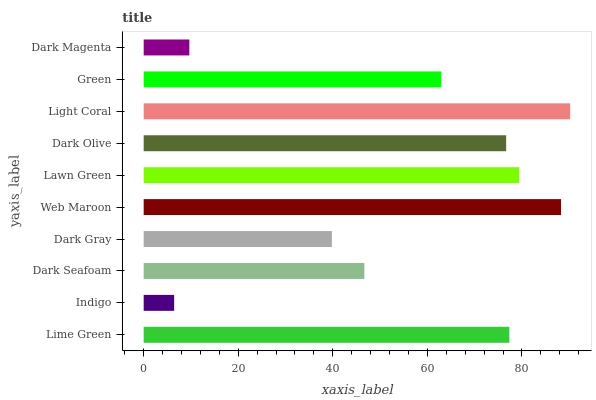Is Indigo the minimum?
Answer yes or no. Yes. Is Light Coral the maximum?
Answer yes or no. Yes. Is Dark Seafoam the minimum?
Answer yes or no. No. Is Dark Seafoam the maximum?
Answer yes or no. No. Is Dark Seafoam greater than Indigo?
Answer yes or no. Yes. Is Indigo less than Dark Seafoam?
Answer yes or no. Yes. Is Indigo greater than Dark Seafoam?
Answer yes or no. No. Is Dark Seafoam less than Indigo?
Answer yes or no. No. Is Dark Olive the high median?
Answer yes or no. Yes. Is Green the low median?
Answer yes or no. Yes. Is Green the high median?
Answer yes or no. No. Is Dark Magenta the low median?
Answer yes or no. No. 